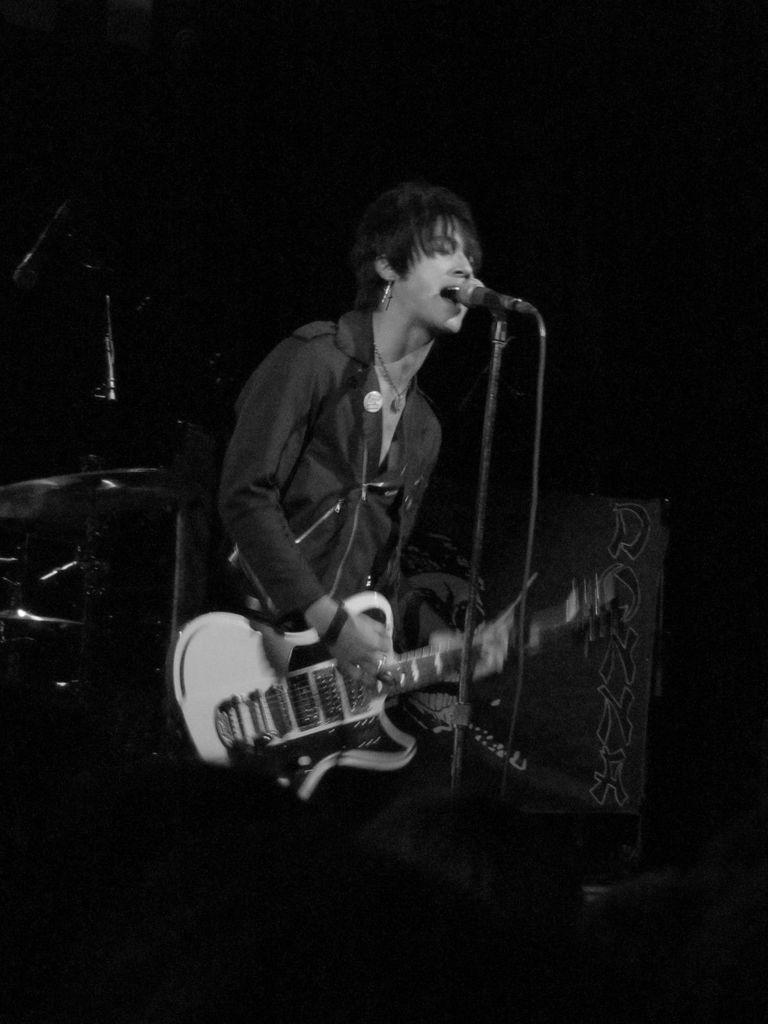Who is the main subject in the image? There is a woman in the image. What is the woman doing in the image? The woman is playing a guitar and singing. What objects are present in the image related to the woman's performance? There is a microphone in front of the woman and a drum behind her. Can you tell me how many buttons are on the woman's shirt in the image? There is no information about the woman's shirt or the presence of buttons in the image. 